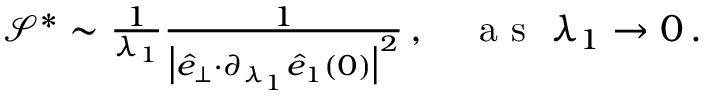Convert formula to latex. <formula><loc_0><loc_0><loc_500><loc_500>\begin{array} { r } { \mathcal { S } ^ { * } \sim \frac { 1 } { \lambda _ { 1 } } \frac { 1 } { \left | \hat { e } _ { \perp } { \cdot } \partial _ { \lambda _ { 1 } } \hat { e } _ { 1 } ( 0 ) \right | ^ { 2 } } \, , a s \lambda _ { 1 } \rightarrow 0 \, . } \end{array}</formula> 